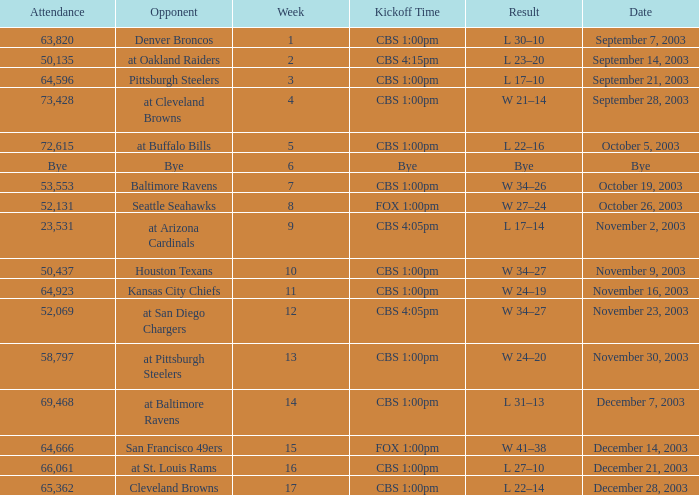What was the result of the game played on November 23, 2003? W 34–27. 